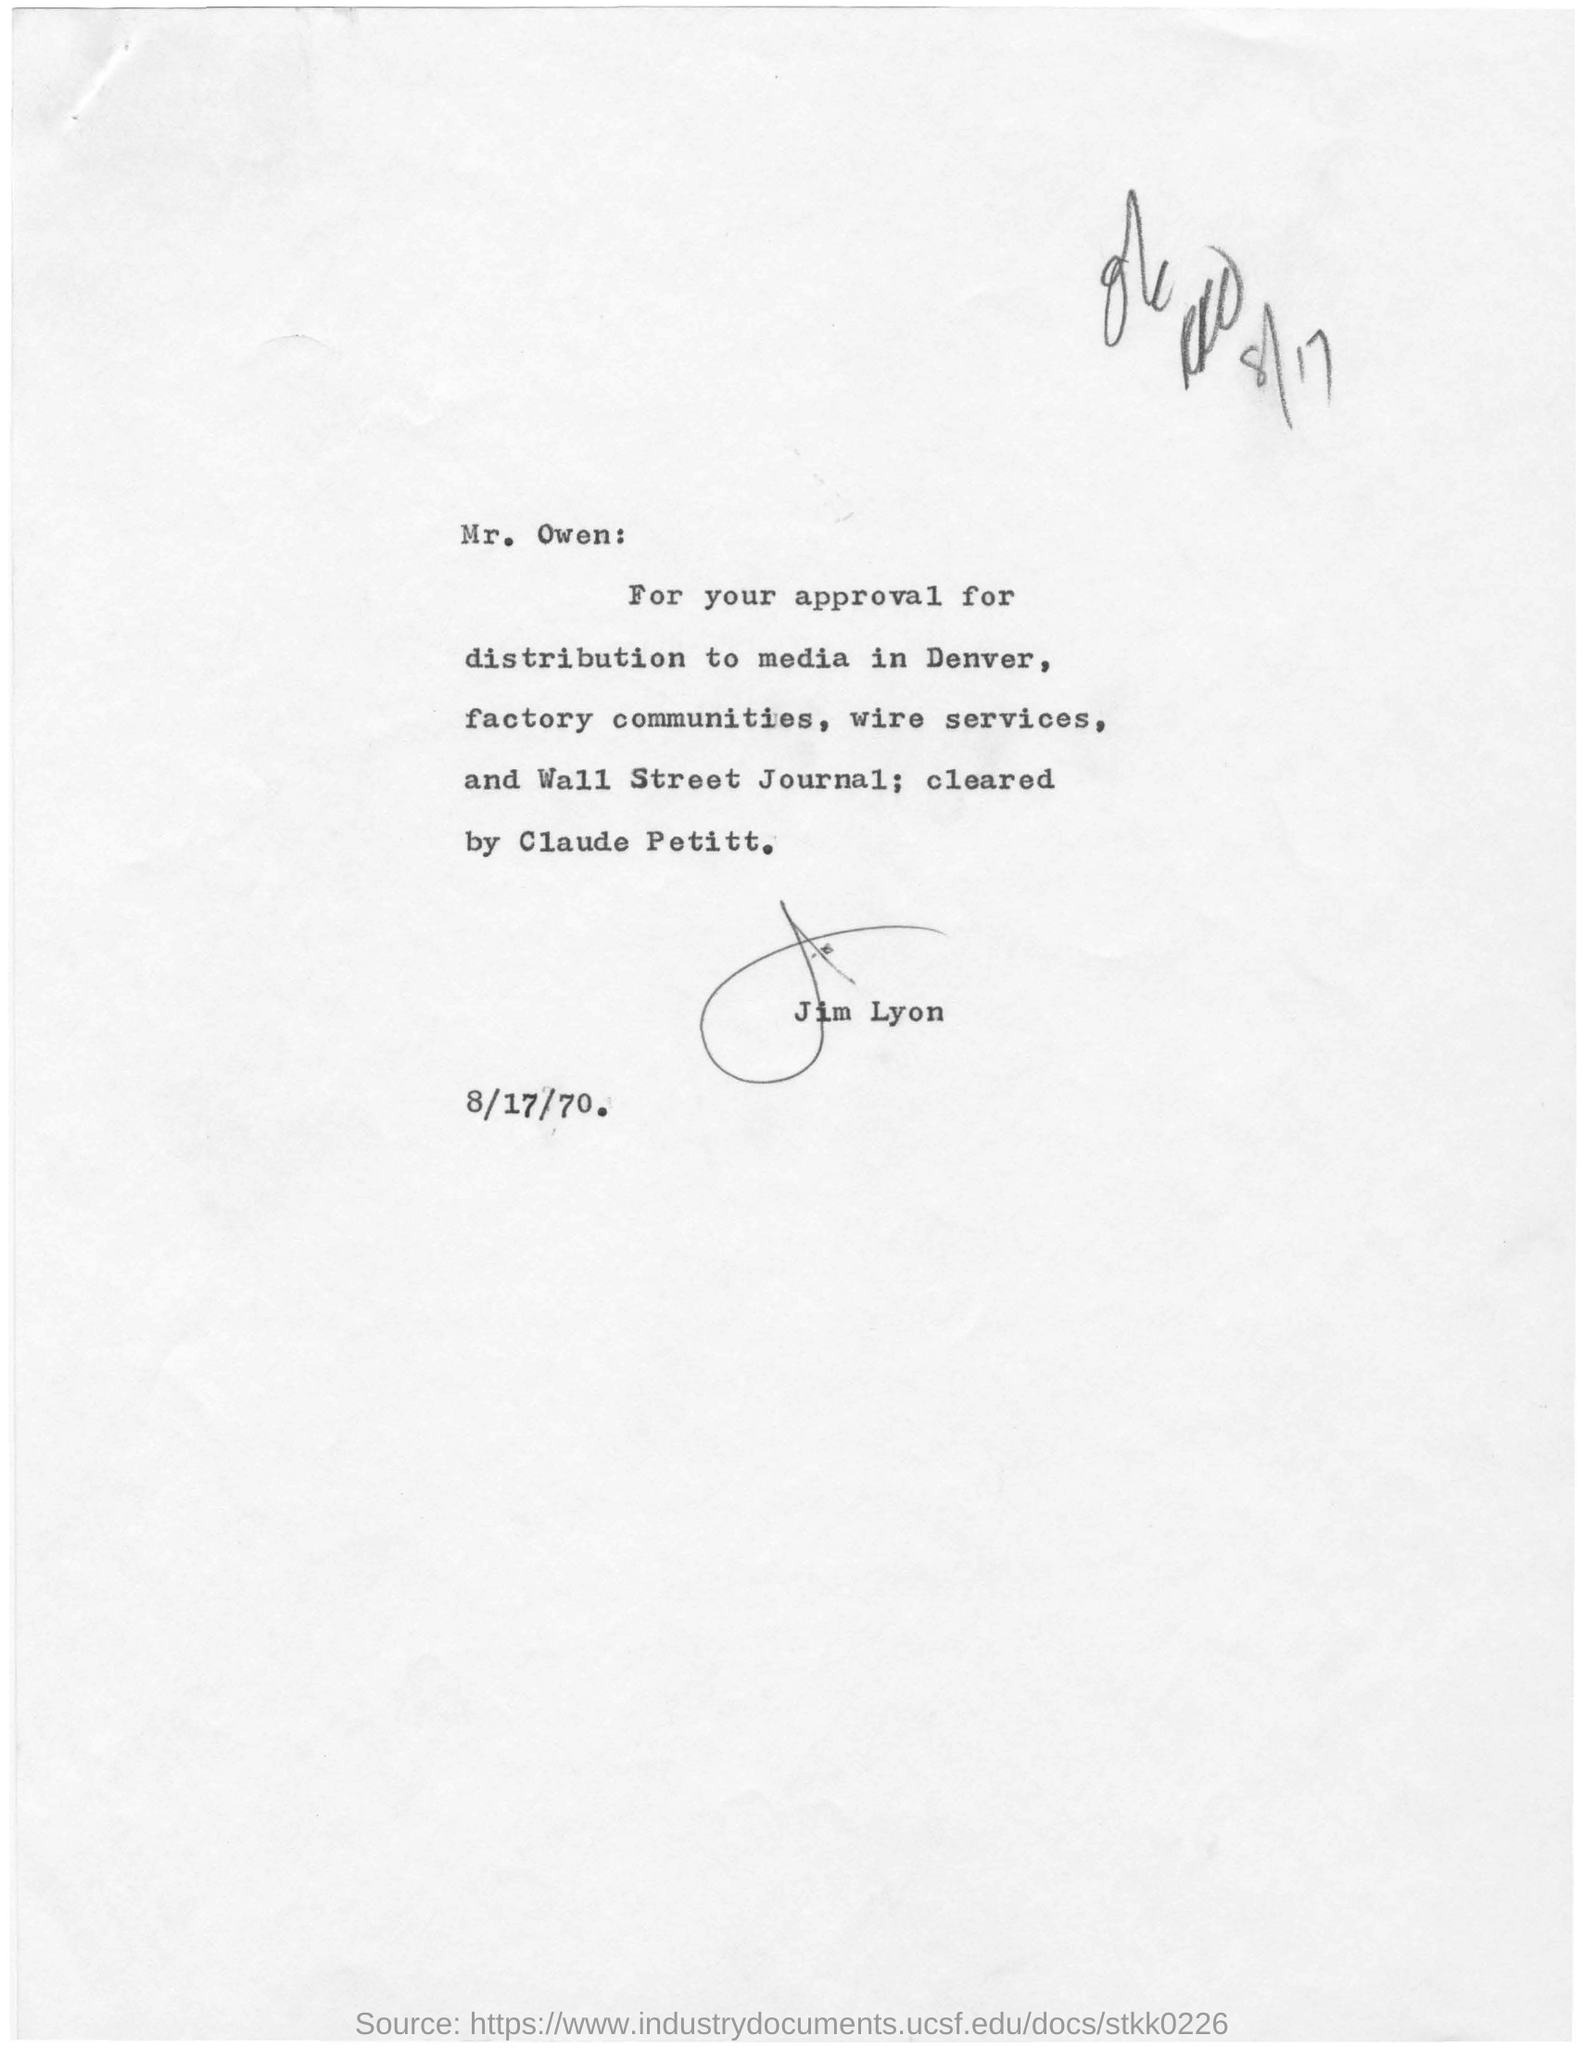What is the date mentioned in the given page ?
Give a very brief answer. 8/17/70. Who's sign was there at the bottom of the letter ?
Provide a short and direct response. Jim Lyon. To whom the letter was written ?
Your answer should be compact. Mr. Owen. 